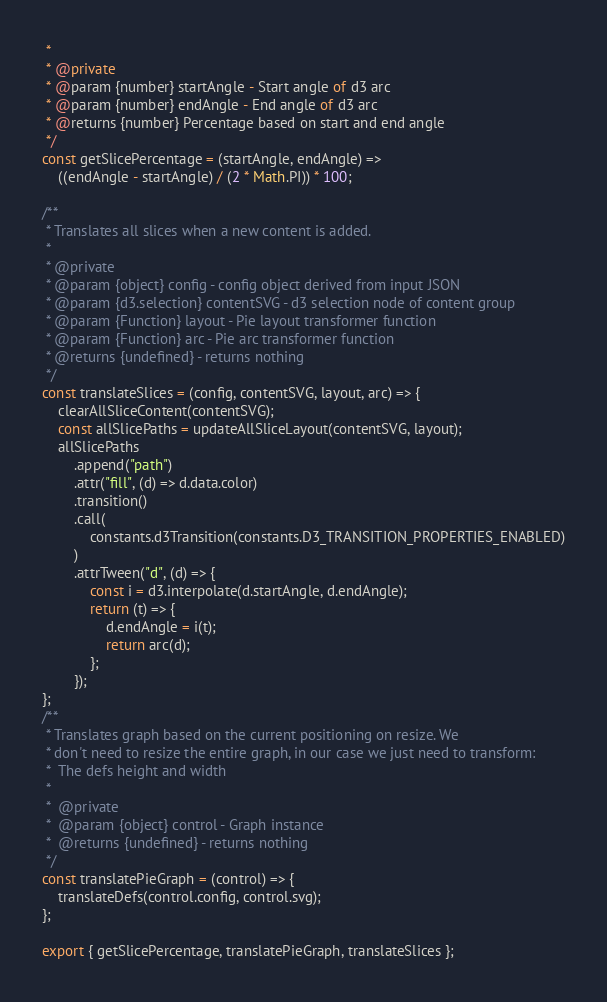Convert code to text. <code><loc_0><loc_0><loc_500><loc_500><_JavaScript_> *
 * @private
 * @param {number} startAngle - Start angle of d3 arc
 * @param {number} endAngle - End angle of d3 arc
 * @returns {number} Percentage based on start and end angle
 */
const getSlicePercentage = (startAngle, endAngle) =>
    ((endAngle - startAngle) / (2 * Math.PI)) * 100;

/**
 * Translates all slices when a new content is added.
 *
 * @private
 * @param {object} config - config object derived from input JSON
 * @param {d3.selection} contentSVG - d3 selection node of content group
 * @param {Function} layout - Pie layout transformer function
 * @param {Function} arc - Pie arc transformer function
 * @returns {undefined} - returns nothing
 */
const translateSlices = (config, contentSVG, layout, arc) => {
    clearAllSliceContent(contentSVG);
    const allSlicePaths = updateAllSliceLayout(contentSVG, layout);
    allSlicePaths
        .append("path")
        .attr("fill", (d) => d.data.color)
        .transition()
        .call(
            constants.d3Transition(constants.D3_TRANSITION_PROPERTIES_ENABLED)
        )
        .attrTween("d", (d) => {
            const i = d3.interpolate(d.startAngle, d.endAngle);
            return (t) => {
                d.endAngle = i(t);
                return arc(d);
            };
        });
};
/**
 * Translates graph based on the current positioning on resize. We
 * don't need to resize the entire graph, in our case we just need to transform:
 *  The defs height and width
 *
 *  @private
 *  @param {object} control - Graph instance
 *  @returns {undefined} - returns nothing
 */
const translatePieGraph = (control) => {
    translateDefs(control.config, control.svg);
};

export { getSlicePercentage, translatePieGraph, translateSlices };
</code> 